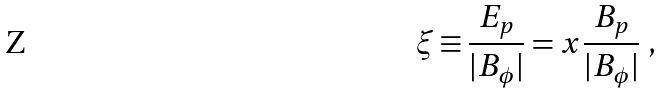Convert formula to latex. <formula><loc_0><loc_0><loc_500><loc_500>\xi \equiv \frac { E _ { p } } { | B _ { \phi } | } = x \frac { B _ { p } } { | B _ { \phi } | } \ ,</formula> 